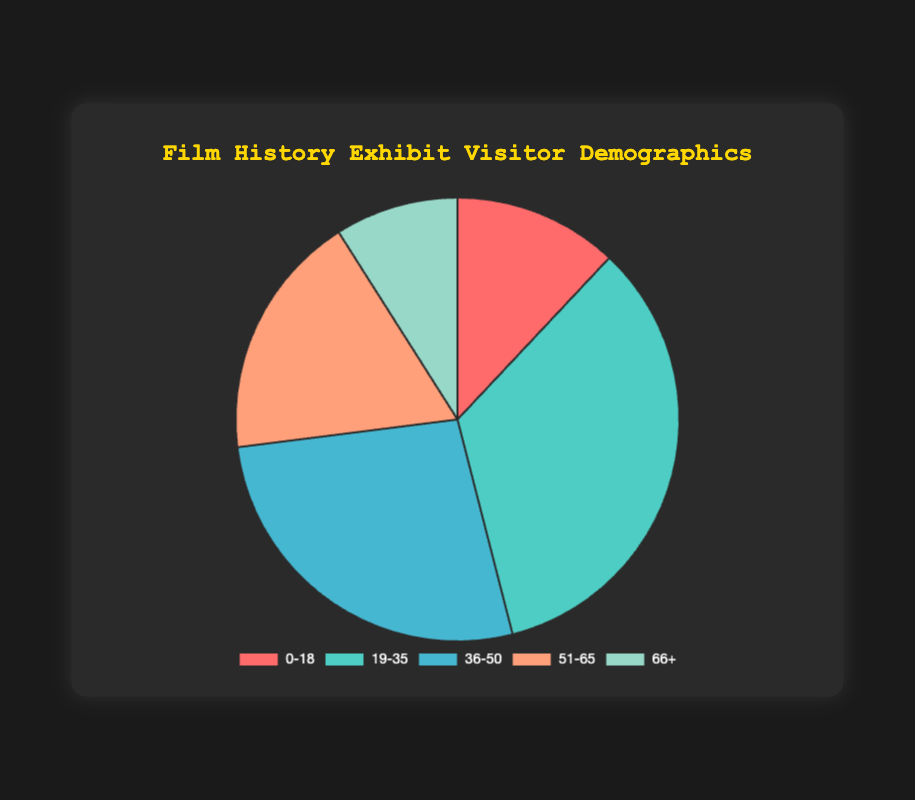What percentage of visitors are aged 19-35? This age group has a segment labeled 34% in the pie chart.
Answer: 34% Which age group has the smallest representation in the visitor demographics? By looking at the pie chart, the segment with the smallest percentage is 66+, which is labeled 9%.
Answer: 66+ How many age groups have a representation of 20% or more? Only the 19-35 age group (34%) and the 36-50 age group (27%) exceed 20%. Therefore, there are 2 age groups.
Answer: 2 Which age group is larger: 51-65 or 66+? The 51-65 age group has 18%, whereas the 66+ age group has 9%. Therefore, the 51-65 age group is larger.
Answer: 51-65 What is the total percentage of visitors who are either under 18 or over 65? Sum the percentages of the 0-18 (12%) and 66+ (9%) age groups: 12% + 9% = 21%.
Answer: 21% How much larger is the 19-35 age group compared to the 51-65 age group? Subtract the 51-65 percentage (18%) from the 19-35 percentage (34%): 34% - 18% = 16%.
Answer: 16% Which age group has the green color segment in the pie chart? By examining the legend and color segments, the green color corresponds to the 19-35 age group.
Answer: 19-35 What is the average percentage of visitors in the age groups between 0-18 and 51-65 inclusive? To find the average: add the percentages (12% + 34% + 27% + 18%) and divide by 4: (12 + 34 + 27 + 18) / 4 = 22.75%.
Answer: 22.75% Are there more visitors in the combined age groups of 0-18 and 36-50 than in the 19-35 group? Sum the percentages of 0-18 (12%) and 36-50 (27%) and compare with 19-35 (34%): 12% + 27% = 39%, which is greater than 34%.
Answer: Yes 